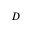<formula> <loc_0><loc_0><loc_500><loc_500>D</formula> 